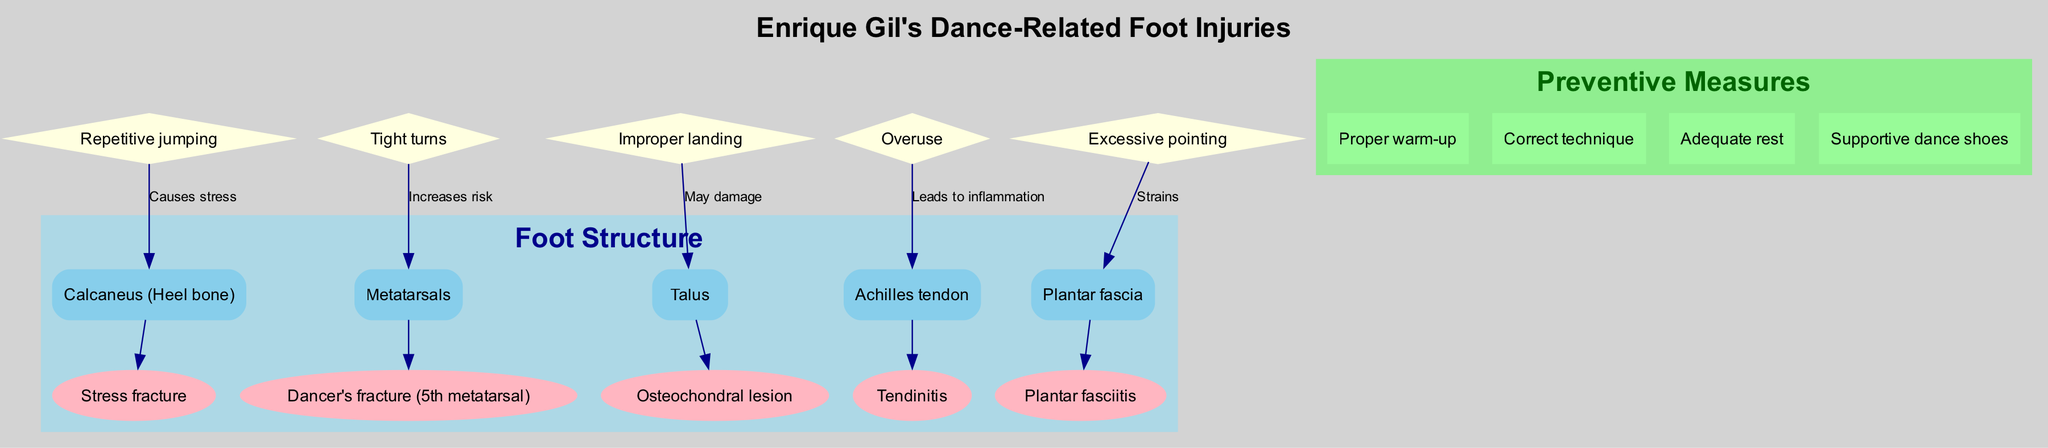What injuries are associated with the calcaneus? The diagram clearly indicates that the calcaneus (heel bone) is associated with a stress fracture. By examining the node for calcaneus, we can directly see the connected injury label.
Answer: Stress fracture How many injuries are linked to the metatarsals? Looking at the metatarsals node in the diagram, there is only one injury listed: dancer's fracture (5th metatarsal). Hence, the total is determined by counting the injuries connected to this node.
Answer: 1 What causes stress to the calcaneus? In the diagram, the connection labeled "Causes stress" indicates that repetitive jumping is the cause of stress to the calcaneus. By following the arrow from the 'Repetitive jumping' node to the 'Calcaneus', we identify this cause directly.
Answer: Repetitive jumping Which component has an injury related to tendinitis? The diagram shows that the Achilles tendon is linked to tendinitis. By checking the injury list under the Achilles tendon, we can find the relevant injury explicitly mentioned there.
Answer: Achilles tendon What preventive measure is suggested for dance-related injuries? Among the listed preventive measures in the diagram, proper warm-up is explicitly mentioned as a key suggestion for preventing injuries. You can see this measure under the preventive measures section.
Answer: Proper warm-up If a dancer experiences inflammation, which anatomical structure is likely affected? Referring to the diagram, we can see that overuse leads to inflammation specifically affecting the Achilles tendon. By following the connection from 'Overuse,' we understand that this structure is associated with such injuries.
Answer: Achilles tendon How many components in the diagram illustrate injuries? The diagram contains five main components, each illustrating specific injuries associated with parts of the foot such as the calcaneus, metatarsals, talus, Achilles tendon, and plantar fascia. Counting these components gives us the number.
Answer: 5 Which injury is caused by excessive pointing? As per the diagram, excessive pointing strains the plantar fascia. Following the connection that leads from 'Excessive pointing' to 'Plantar fascia' shows this relationship clearly.
Answer: Plantar fasciitis What types of injuries are caused by improper landing? By checking the diagram, it becomes clear that improper landing may damage the talus, specifically showing the connection that leads from 'Improper landing' to the talus injury.
Answer: Osteochondral lesion 